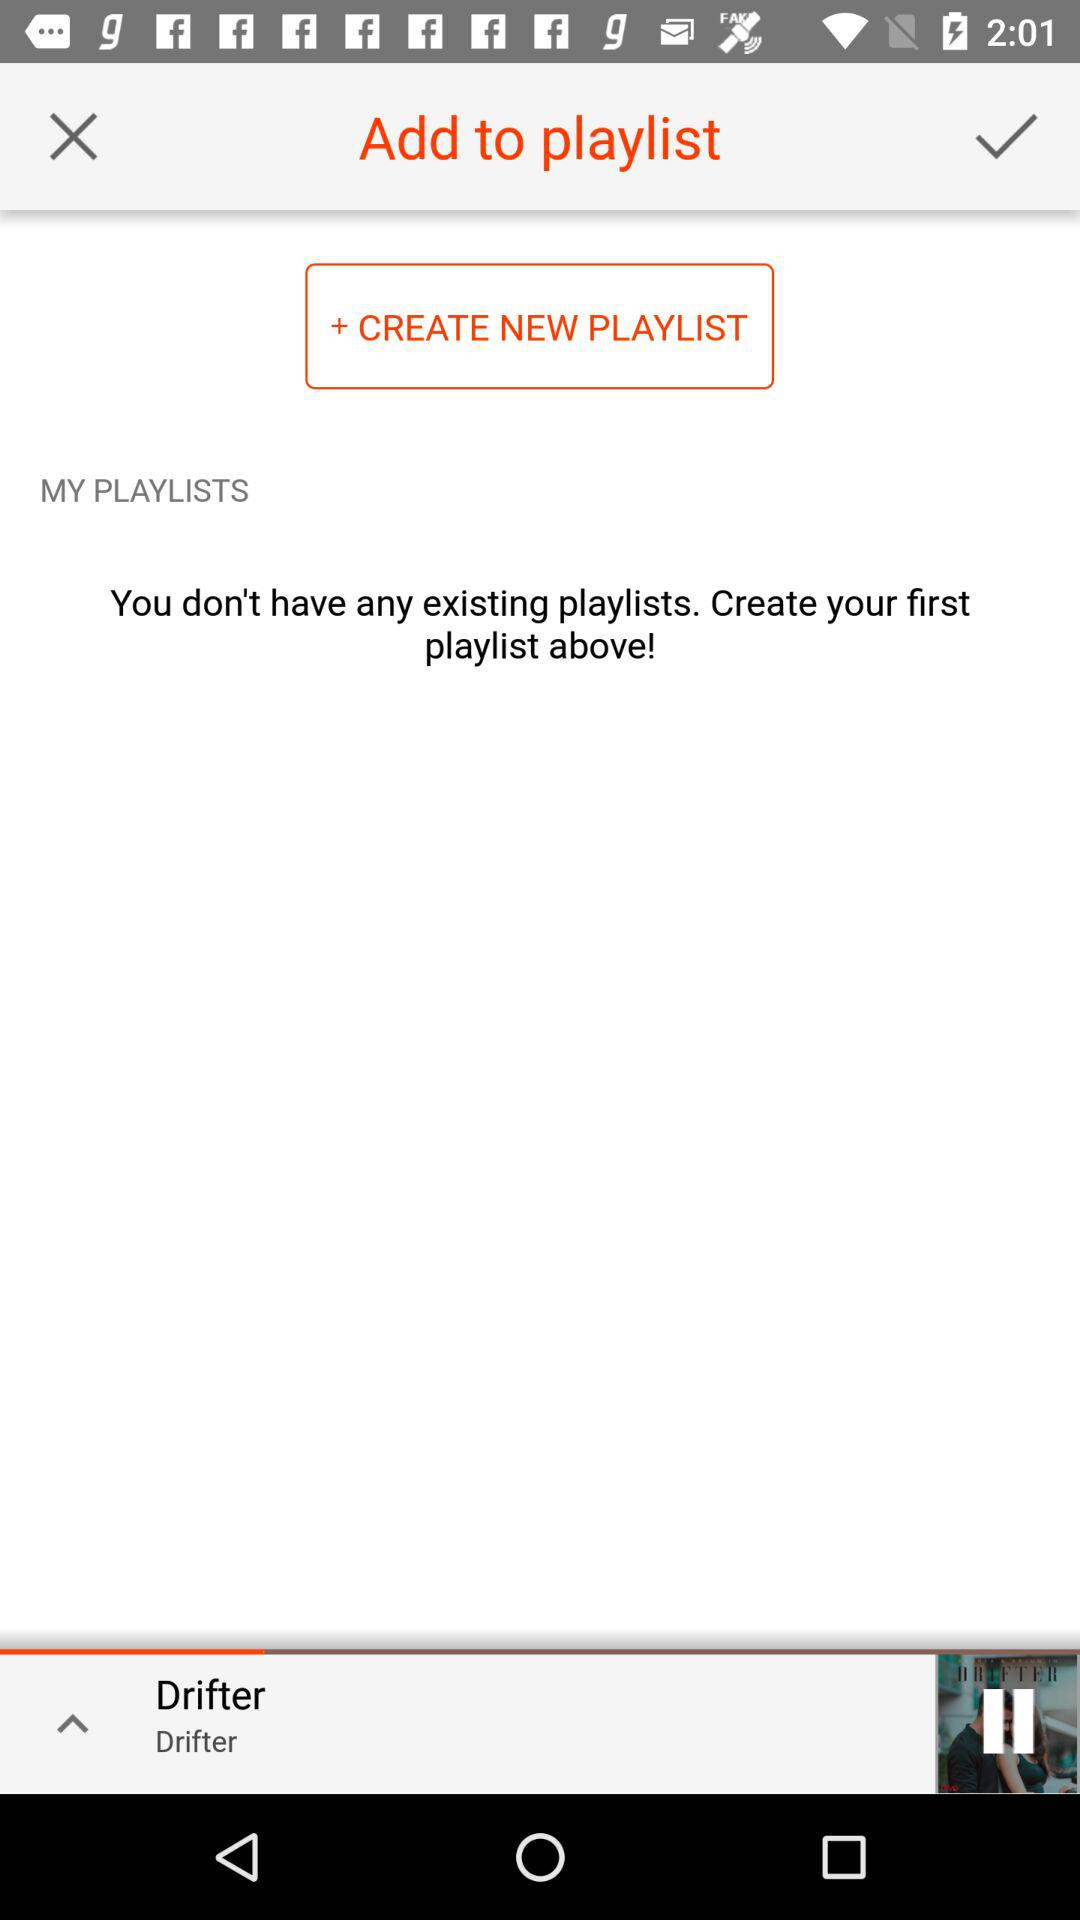What is the name of the audio that is playing? The name of the audio that is playing is "Drifter". 